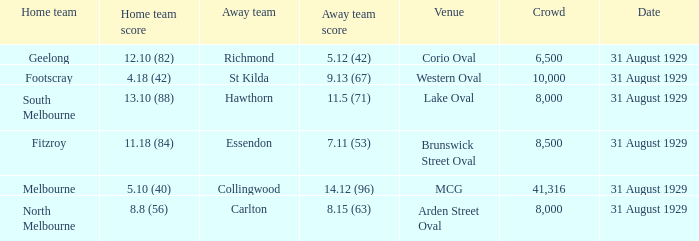What was the score of the home team when the away team scored 14.12 (96)? 5.10 (40). 